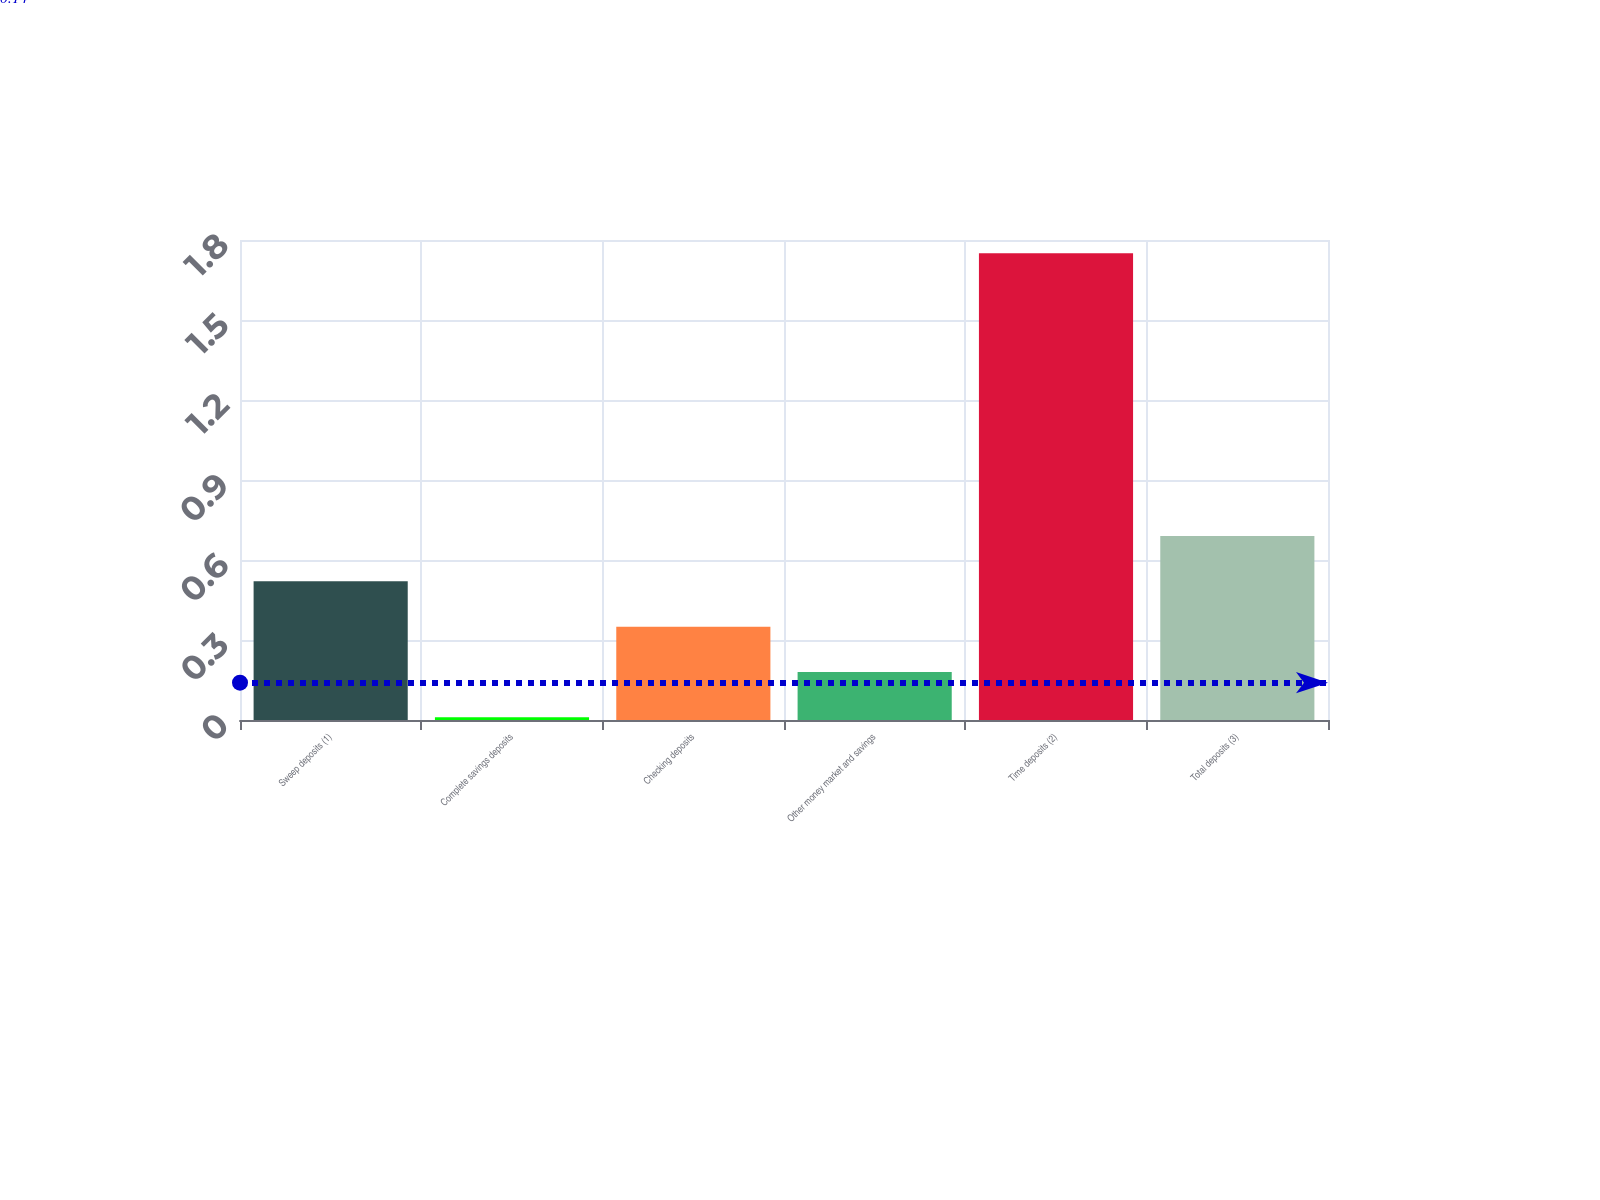<chart> <loc_0><loc_0><loc_500><loc_500><bar_chart><fcel>Sweep deposits (1)<fcel>Complete savings deposits<fcel>Checking deposits<fcel>Other money market and savings<fcel>Time deposits (2)<fcel>Total deposits (3)<nl><fcel>0.52<fcel>0.01<fcel>0.35<fcel>0.18<fcel>1.75<fcel>0.69<nl></chart> 